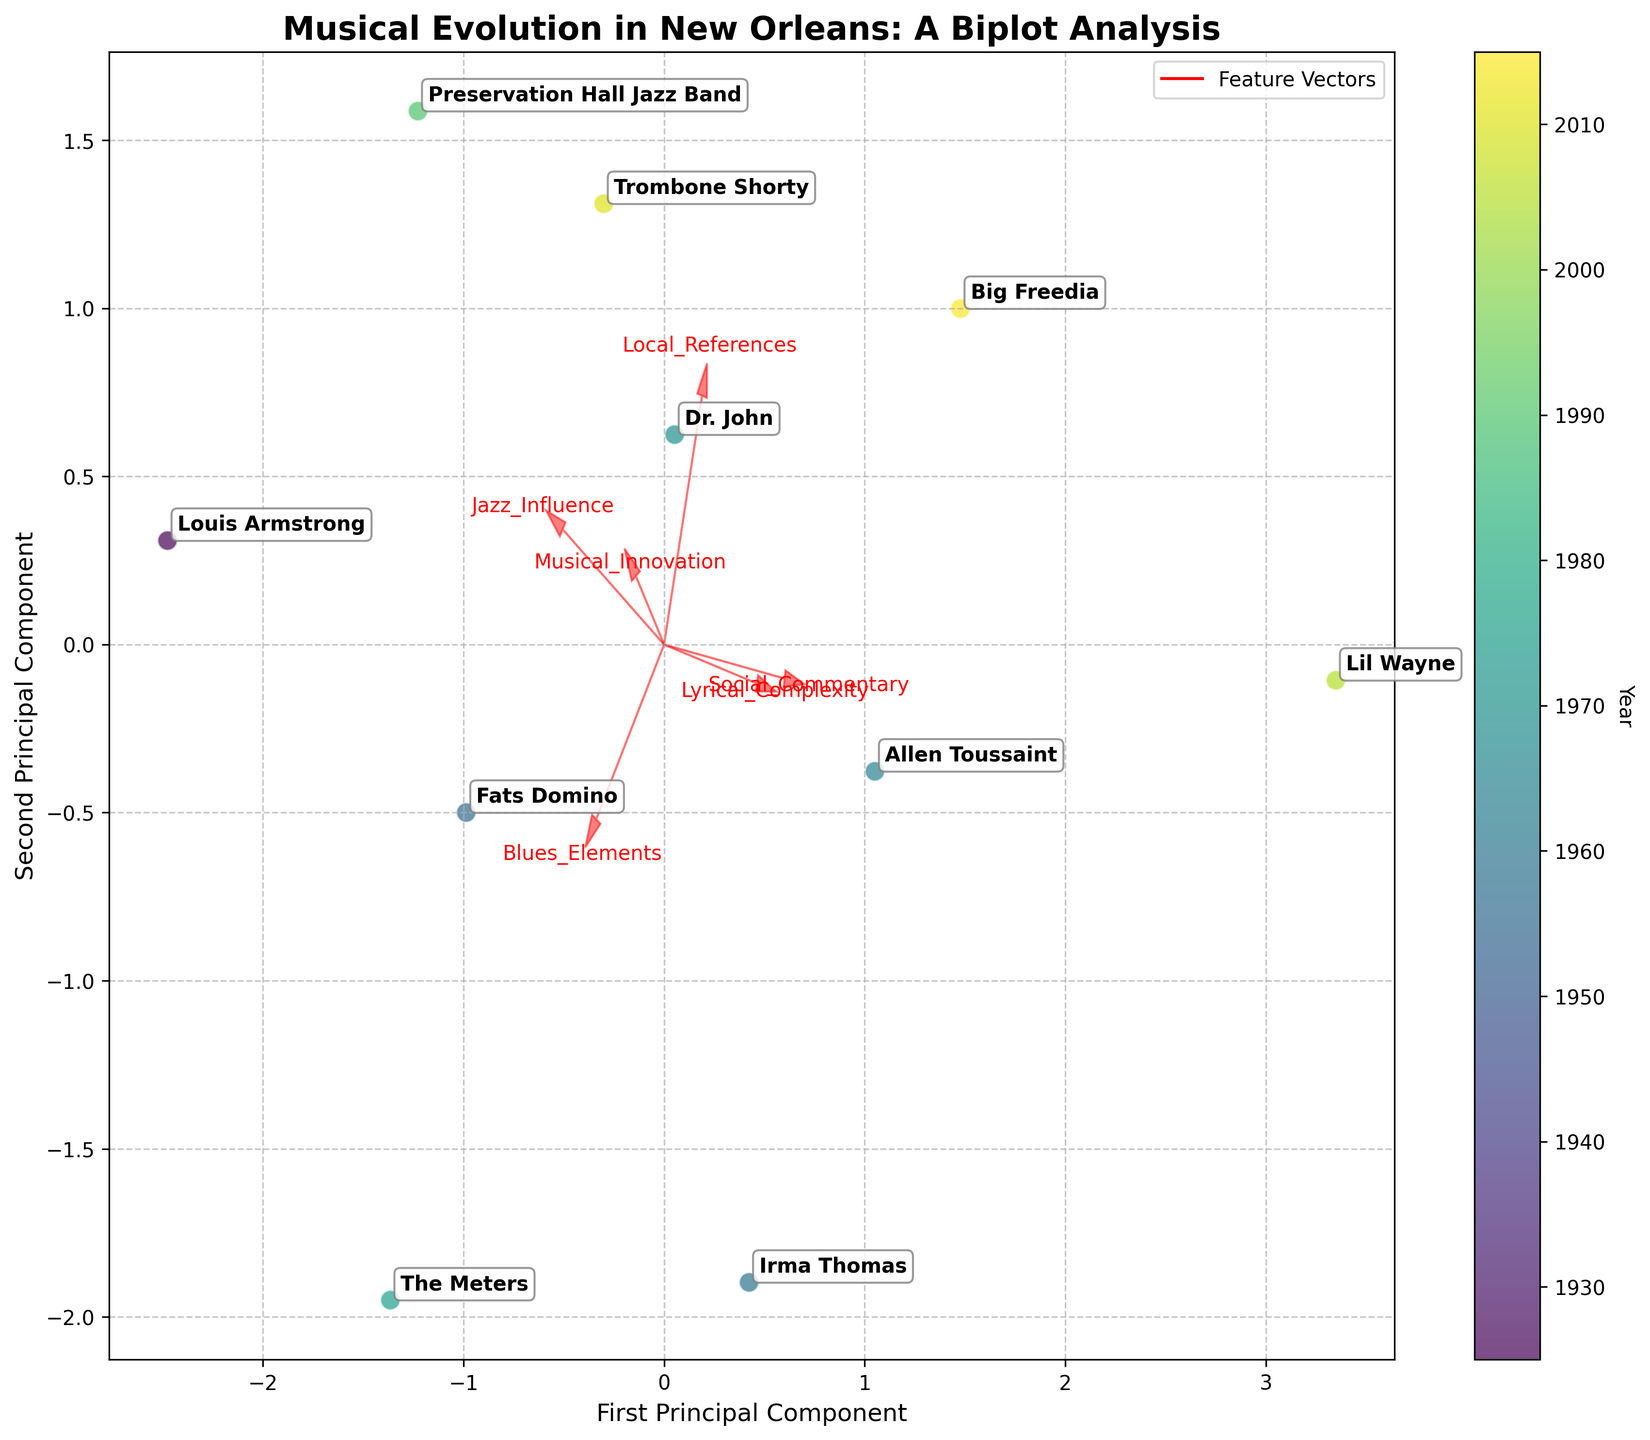What is the title of the plot? The title of the plot is prominently displayed at the top center of the figure. It indicates the main theme of the plot.
Answer: Musical Evolution in New Orleans: A Biplot Analysis Which artist has the highest value in Musical Innovation? To determine the artist with the highest value in Musical Innovation, one can compare the position of data points along the primary component correlated with Musical Innovation. Look for the artist with the highest projection on this axis.
Answer: Dr. John Which artist is closest to the origin (0,0) in the biplot? By examining the positions of all artists in the plot, the artist closest to the origin (the intersection of x and y axes) can be identified. This involves determining the smallest Euclidean distance to (0,0).
Answer: Preservation Hall Jazz Band Between Trombone Shorty and Big Freedia, whose music has more Jazz Influence? Look at the vector representing Jazz Influence and compare the projections of Trombone Shorty and Big Freedia on this vector.
Answer: Trombone Shorty What does the direction of the Social Commentary vector indicate? The direction of each vector indicates the principal component loadings. For Social Commentary, this direction signifies the alignment and contribution of this feature to the principal components.
Answer: It shows how strongly Social Commentary is aligned with the principal components How are the artists distributed over the timeline represented in the colorbar? Examine the colorbar and match the colors to the corresponding artists. This will show how artists are distributed over different years.
Answer: Artists are spread across various years from 1925 to 2015 Which feature has a significant positive correlation with the first principal component? By looking at the vectors radiating from the origin, the feature whose vector points prominently along the direction of the first principal component (x-axis) indicates a positive correlation.
Answer: Musical Innovation Who are the artists with high values in both Local References and Blues Elements? Check the artists’ positions relative to the vectors for Local References and Blues Elements. Those far along both vectors show high values in these features.
Answer: Dr. John and Trombone Shorty Which two artists have the most distinct differences in their musical characteristics? To find the most distinct differences, look for artists that are placed farthest apart in the biplot, which suggests large variations in their attributes.
Answer: Louis Armstrong and Lil Wayne What feature appears to have the least influence on the artists' distribution in the biplot? Identify the shortest vector or the vector least aligned with the principal components, indicating a lesser influence.
Answer: Social Commentary 